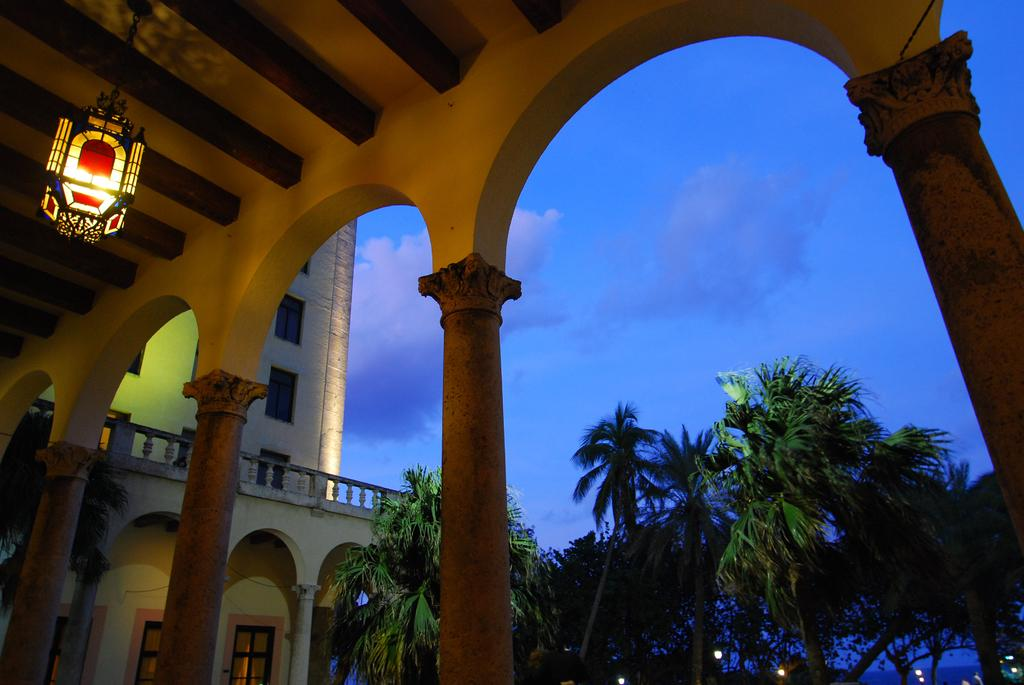What object can be seen in the image that provides light? There is a lamp in the image that provides light. What architectural features are present in the image? There are pillars and a building in the image. What part of the building can be seen in the image? There are windows in the image that show part of the building. What other light sources are visible in the image? There are lights in the image. What type of vegetation is present in the image? There are trees in the image. What can be seen in the background of the image? The sky with clouds is visible in the background of the image. How does the lamp feel about the rail in the image? There is no rail present in the image, and therefore the lamp cannot have any feelings about it. 